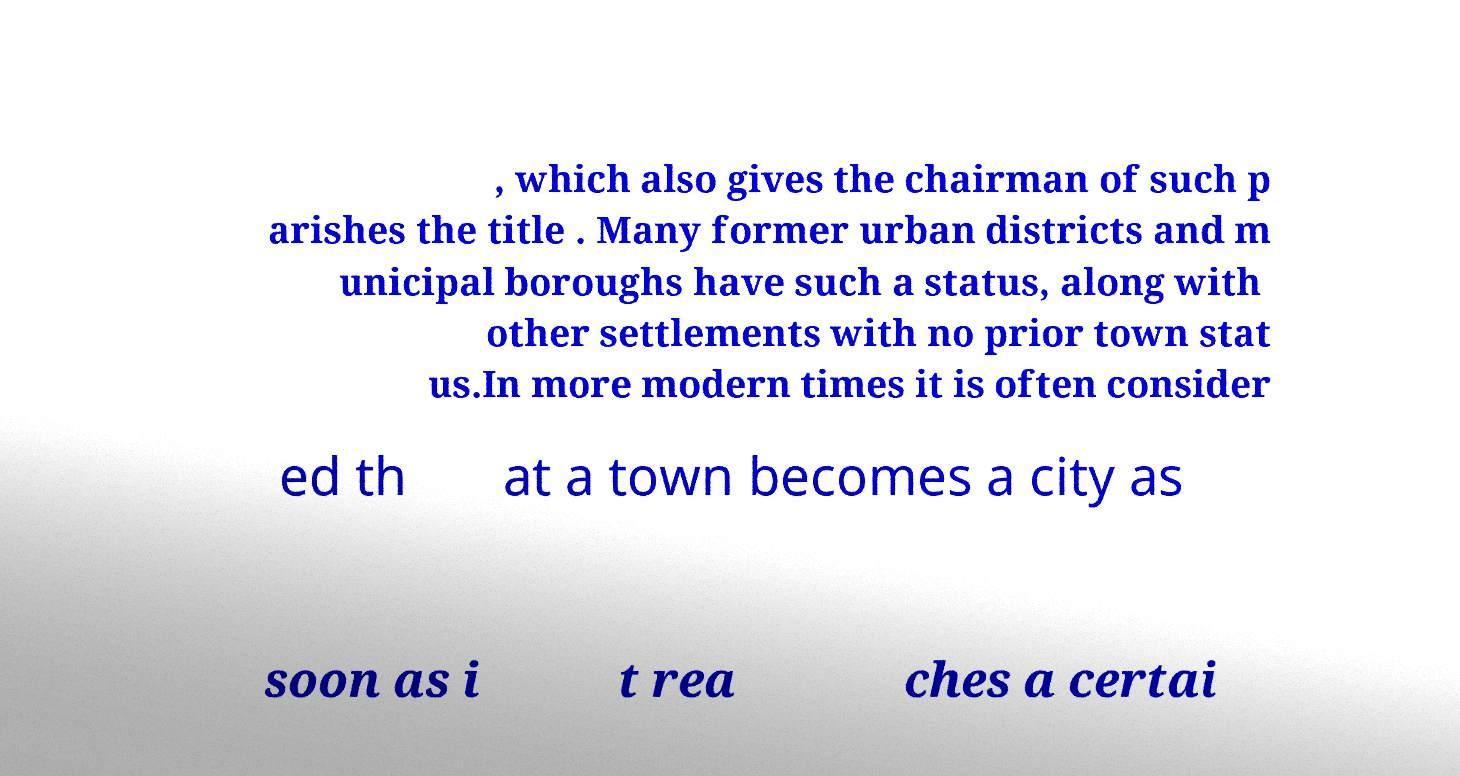What messages or text are displayed in this image? I need them in a readable, typed format. , which also gives the chairman of such p arishes the title . Many former urban districts and m unicipal boroughs have such a status, along with other settlements with no prior town stat us.In more modern times it is often consider ed th at a town becomes a city as soon as i t rea ches a certai 